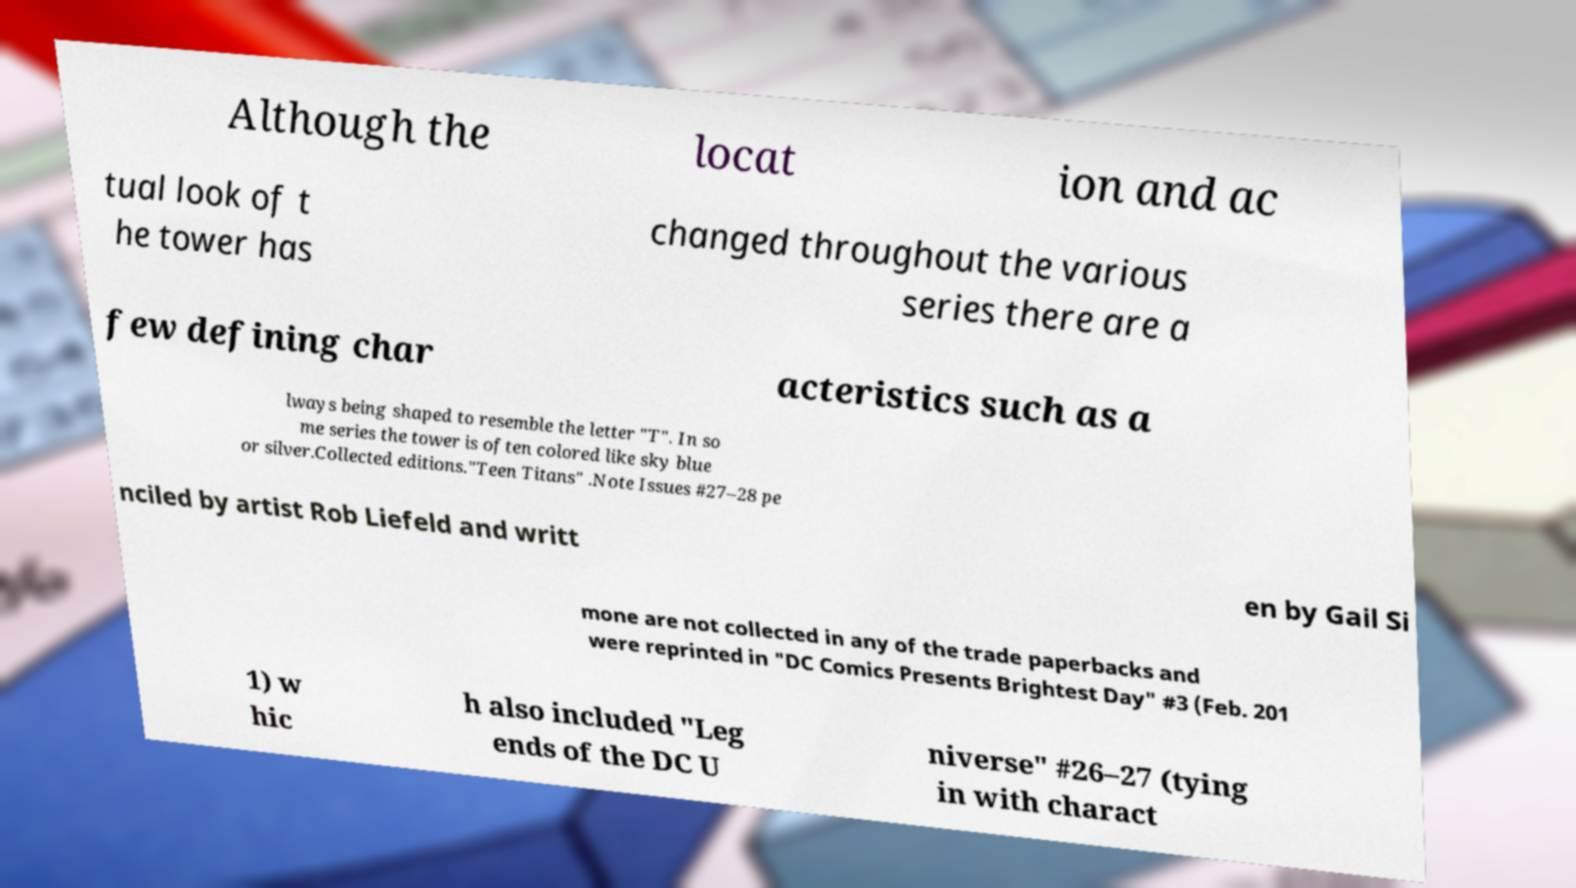For documentation purposes, I need the text within this image transcribed. Could you provide that? Although the locat ion and ac tual look of t he tower has changed throughout the various series there are a few defining char acteristics such as a lways being shaped to resemble the letter "T". In so me series the tower is often colored like sky blue or silver.Collected editions."Teen Titans" .Note Issues #27–28 pe nciled by artist Rob Liefeld and writt en by Gail Si mone are not collected in any of the trade paperbacks and were reprinted in "DC Comics Presents Brightest Day" #3 (Feb. 201 1) w hic h also included "Leg ends of the DC U niverse" #26–27 (tying in with charact 